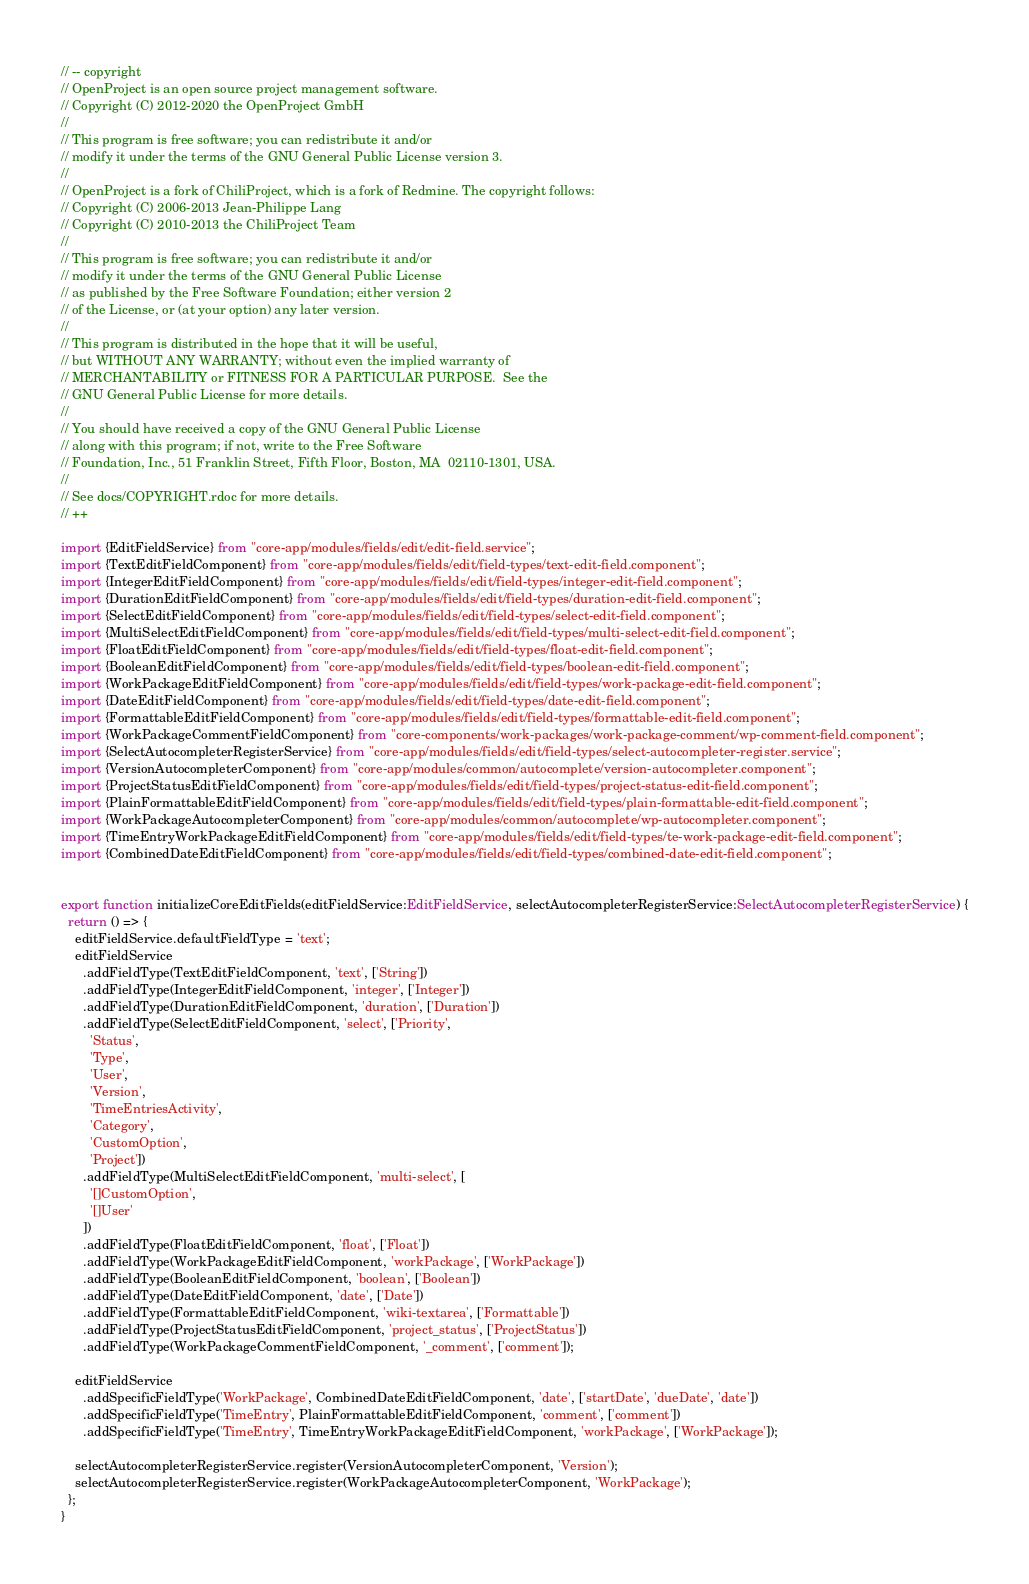Convert code to text. <code><loc_0><loc_0><loc_500><loc_500><_TypeScript_>// -- copyright
// OpenProject is an open source project management software.
// Copyright (C) 2012-2020 the OpenProject GmbH
//
// This program is free software; you can redistribute it and/or
// modify it under the terms of the GNU General Public License version 3.
//
// OpenProject is a fork of ChiliProject, which is a fork of Redmine. The copyright follows:
// Copyright (C) 2006-2013 Jean-Philippe Lang
// Copyright (C) 2010-2013 the ChiliProject Team
//
// This program is free software; you can redistribute it and/or
// modify it under the terms of the GNU General Public License
// as published by the Free Software Foundation; either version 2
// of the License, or (at your option) any later version.
//
// This program is distributed in the hope that it will be useful,
// but WITHOUT ANY WARRANTY; without even the implied warranty of
// MERCHANTABILITY or FITNESS FOR A PARTICULAR PURPOSE.  See the
// GNU General Public License for more details.
//
// You should have received a copy of the GNU General Public License
// along with this program; if not, write to the Free Software
// Foundation, Inc., 51 Franklin Street, Fifth Floor, Boston, MA  02110-1301, USA.
//
// See docs/COPYRIGHT.rdoc for more details.
// ++

import {EditFieldService} from "core-app/modules/fields/edit/edit-field.service";
import {TextEditFieldComponent} from "core-app/modules/fields/edit/field-types/text-edit-field.component";
import {IntegerEditFieldComponent} from "core-app/modules/fields/edit/field-types/integer-edit-field.component";
import {DurationEditFieldComponent} from "core-app/modules/fields/edit/field-types/duration-edit-field.component";
import {SelectEditFieldComponent} from "core-app/modules/fields/edit/field-types/select-edit-field.component";
import {MultiSelectEditFieldComponent} from "core-app/modules/fields/edit/field-types/multi-select-edit-field.component";
import {FloatEditFieldComponent} from "core-app/modules/fields/edit/field-types/float-edit-field.component";
import {BooleanEditFieldComponent} from "core-app/modules/fields/edit/field-types/boolean-edit-field.component";
import {WorkPackageEditFieldComponent} from "core-app/modules/fields/edit/field-types/work-package-edit-field.component";
import {DateEditFieldComponent} from "core-app/modules/fields/edit/field-types/date-edit-field.component";
import {FormattableEditFieldComponent} from "core-app/modules/fields/edit/field-types/formattable-edit-field.component";
import {WorkPackageCommentFieldComponent} from "core-components/work-packages/work-package-comment/wp-comment-field.component";
import {SelectAutocompleterRegisterService} from "core-app/modules/fields/edit/field-types/select-autocompleter-register.service";
import {VersionAutocompleterComponent} from "core-app/modules/common/autocomplete/version-autocompleter.component";
import {ProjectStatusEditFieldComponent} from "core-app/modules/fields/edit/field-types/project-status-edit-field.component";
import {PlainFormattableEditFieldComponent} from "core-app/modules/fields/edit/field-types/plain-formattable-edit-field.component";
import {WorkPackageAutocompleterComponent} from "core-app/modules/common/autocomplete/wp-autocompleter.component";
import {TimeEntryWorkPackageEditFieldComponent} from "core-app/modules/fields/edit/field-types/te-work-package-edit-field.component";
import {CombinedDateEditFieldComponent} from "core-app/modules/fields/edit/field-types/combined-date-edit-field.component";


export function initializeCoreEditFields(editFieldService:EditFieldService, selectAutocompleterRegisterService:SelectAutocompleterRegisterService) {
  return () => {
    editFieldService.defaultFieldType = 'text';
    editFieldService
      .addFieldType(TextEditFieldComponent, 'text', ['String'])
      .addFieldType(IntegerEditFieldComponent, 'integer', ['Integer'])
      .addFieldType(DurationEditFieldComponent, 'duration', ['Duration'])
      .addFieldType(SelectEditFieldComponent, 'select', ['Priority',
        'Status',
        'Type',
        'User',
        'Version',
        'TimeEntriesActivity',
        'Category',
        'CustomOption',
        'Project'])
      .addFieldType(MultiSelectEditFieldComponent, 'multi-select', [
        '[]CustomOption',
        '[]User'
      ])
      .addFieldType(FloatEditFieldComponent, 'float', ['Float'])
      .addFieldType(WorkPackageEditFieldComponent, 'workPackage', ['WorkPackage'])
      .addFieldType(BooleanEditFieldComponent, 'boolean', ['Boolean'])
      .addFieldType(DateEditFieldComponent, 'date', ['Date'])
      .addFieldType(FormattableEditFieldComponent, 'wiki-textarea', ['Formattable'])
      .addFieldType(ProjectStatusEditFieldComponent, 'project_status', ['ProjectStatus'])
      .addFieldType(WorkPackageCommentFieldComponent, '_comment', ['comment']);

    editFieldService
      .addSpecificFieldType('WorkPackage', CombinedDateEditFieldComponent, 'date', ['startDate', 'dueDate', 'date'])
      .addSpecificFieldType('TimeEntry', PlainFormattableEditFieldComponent, 'comment', ['comment'])
      .addSpecificFieldType('TimeEntry', TimeEntryWorkPackageEditFieldComponent, 'workPackage', ['WorkPackage']);

    selectAutocompleterRegisterService.register(VersionAutocompleterComponent, 'Version');
    selectAutocompleterRegisterService.register(WorkPackageAutocompleterComponent, 'WorkPackage');
  };
}
</code> 